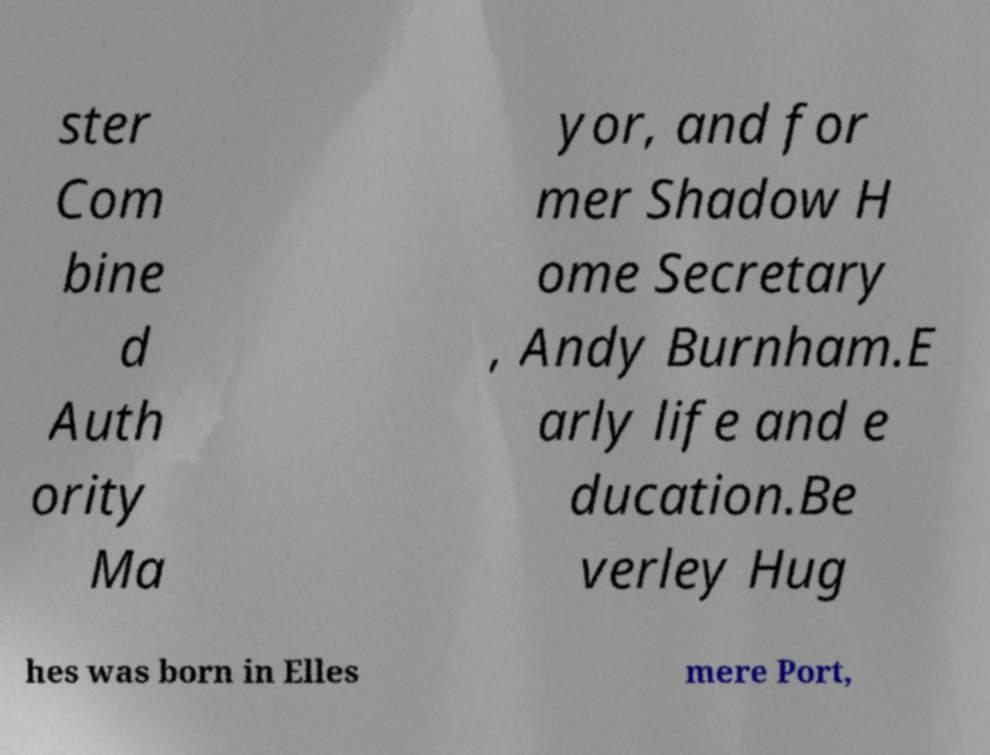There's text embedded in this image that I need extracted. Can you transcribe it verbatim? ster Com bine d Auth ority Ma yor, and for mer Shadow H ome Secretary , Andy Burnham.E arly life and e ducation.Be verley Hug hes was born in Elles mere Port, 